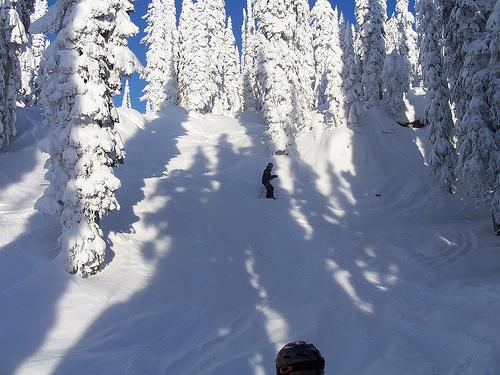What is the most noticeable object or action happening in the image? A person skiing, wearing a black helmet, is the center of attention amidst a snow-laden course with trees. Briefly explain what is happening in the picture. A skier donning a black helmet goes down a slope, in the midst of trees draped in snow. Paint a picture using words about the main focus of the photograph. In the image, a skier donning a black helmet weaves through a winter wonderland filled with trees draped in snow. Provide a concise description of the activities taking place in the image. The picture captures a helmeted skier gliding down a slope surrounded by frosty, snow-covered trees. Identify the primary focus of the image and describe the scene. The image features a person skiing in snowy terrain, wearing a black helmet, surrounded by snow-covered trees. Explain the scene using the main objects and activities present in the image. A person wearing a black helmet is skiing through a landscape dominated by snow-draped trees. Give a brief description of the main subject of the picture and the surroundings. A helmeted skier is seen skiing amidst a beautiful snowy landscape with several snow-covered trees. Write a sentence about the main subject of the image and what is happening. A black-helmeted skier makes their way through a snowy, tree-laden course. Among the objects in the image, identify the primary detail and describe it. The image's focal point is a skier wearing a black helmet navigating through a snowy path filled with frost-covered trees. Write a short description of the main elements in the image. The image depicts a skier with a black helmet navigating through a snowy landscape filled with snow-blanketed trees. 